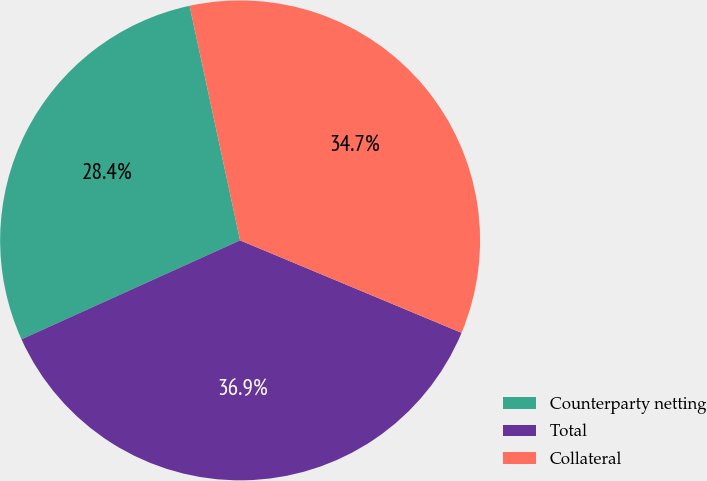Convert chart to OTSL. <chart><loc_0><loc_0><loc_500><loc_500><pie_chart><fcel>Counterparty netting<fcel>Total<fcel>Collateral<nl><fcel>28.39%<fcel>36.94%<fcel>34.67%<nl></chart> 